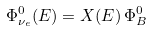Convert formula to latex. <formula><loc_0><loc_0><loc_500><loc_500>\Phi ^ { 0 } _ { \nu _ { e } } ( E ) = X ( E ) \, \Phi ^ { 0 } _ { B }</formula> 